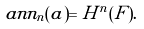Convert formula to latex. <formula><loc_0><loc_0><loc_500><loc_500>\ a n n _ { n } ( a ) = H ^ { n } ( F ) .</formula> 